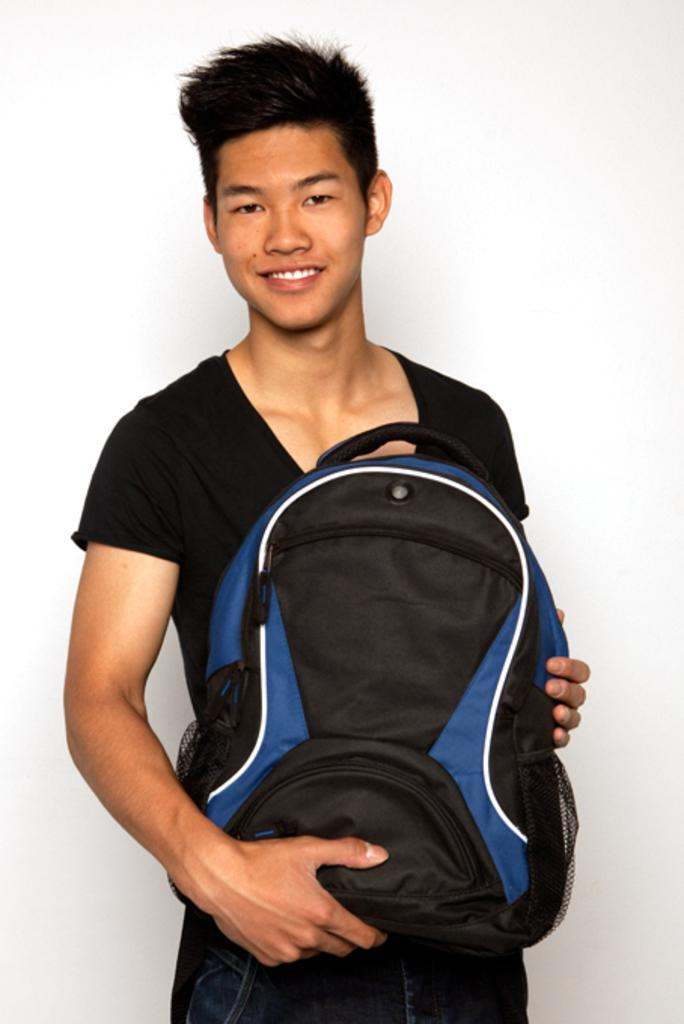Who is present in the image? There is a person in the image. What is the person's facial expression? The person is smiling. What is the person holding in the image? The person is holding a bag. What type of jewel is the person wearing in the image? There is no jewel visible on the person in the image. 